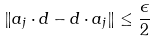<formula> <loc_0><loc_0><loc_500><loc_500>\| a _ { j } \cdot d - d \cdot a _ { j } \| \leq \frac { \epsilon } { 2 }</formula> 